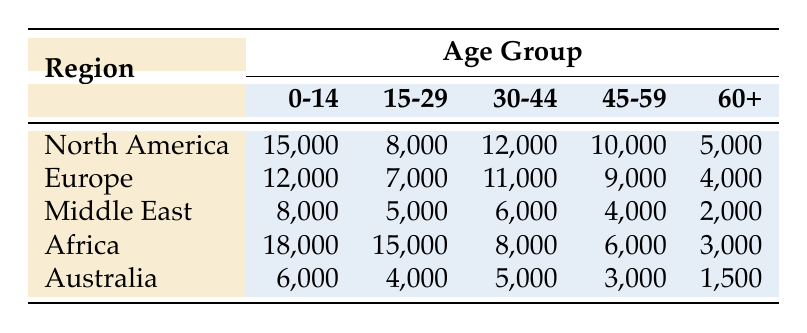What is the total number of congregants aged 0-14 in North America? In the table, for North America, the count of congregants aged 0-14 is listed as 15,000. Therefore, the total number is directly taken from this value.
Answer: 15,000 Which age group has the highest count of congregants in Africa? Looking at the Africa row, the highest number of congregants is in the age group 15-29, with a count of 15,000.
Answer: 15-29 How many more congregants are there in the age group 30-44 in North America compared to the Middle East? For North America, the count in the 30-44 age group is 12,000, and for the Middle East, it is 6,000. The difference is 12,000 - 6,000 = 6,000.
Answer: 6,000 In which region is the count of congregants aged 60+ the lowest? The table shows the counts of congregants aged 60+ for each region: North America (5,000), Europe (4,000), Middle East (2,000), Africa (3,000), and Australia (1,500). The lowest is 1,500 in Australia.
Answer: Australia Calculate the total count of congregants aged 0-14 across all regions. The counts for the 0-14 age group are: North America (15,000), Europe (12,000), Middle East (8,000), Africa (18,000), and Australia (6,000). The total is 15,000 + 12,000 + 8,000 + 18,000 + 6,000 = 59,000.
Answer: 59,000 Are there more congregants aged 15-29 in Europe or North America? For North America, the count is 8,000, while for Europe, it is 7,000. Since 8,000 is greater than 7,000, the answer is North America.
Answer: North America Which two regions have a combined total of 30-44 year-old congregants greater than 20,000? The counts for 30-44 year-olds are: North America (12,000) and Africa (8,000) which add up to 20,000. North America (12,000) and Europe (11,000) add up to 23,000. Therefore, North America and Europe exceed 20,000.
Answer: North America and Europe What is the average number of congregants in the age group 45-59 across all regions? The counts are: North America (10,000), Europe (9,000), Middle East (4,000), Africa (6,000), and Australia (3,000). The total is 10,000 + 9,000 + 4,000 + 6,000 + 3,000 = 32,000 and dividing by 5 gives an average of 32,000 / 5 = 6,400.
Answer: 6,400 Which age group has the smallest number of congregants in the Middle East? In the Middle East, the number of congregants for each age group are: 0-14 (8,000), 15-29 (5,000), 30-44 (6,000), 45-59 (4,000), and 60+ (2,000). The smallest is in the 60+ age group with 2,000.
Answer: 60+ Does Africa have more congregants in the 0-14 age group than North America? Africa has 18,000 in the 0-14 age group while North America has 15,000. Since 18,000 is greater than 15,000, the answer is yes.
Answer: Yes 